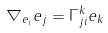<formula> <loc_0><loc_0><loc_500><loc_500>\nabla _ { e _ { i } } e _ { j } = \Gamma _ { j i } ^ { k } e _ { k }</formula> 